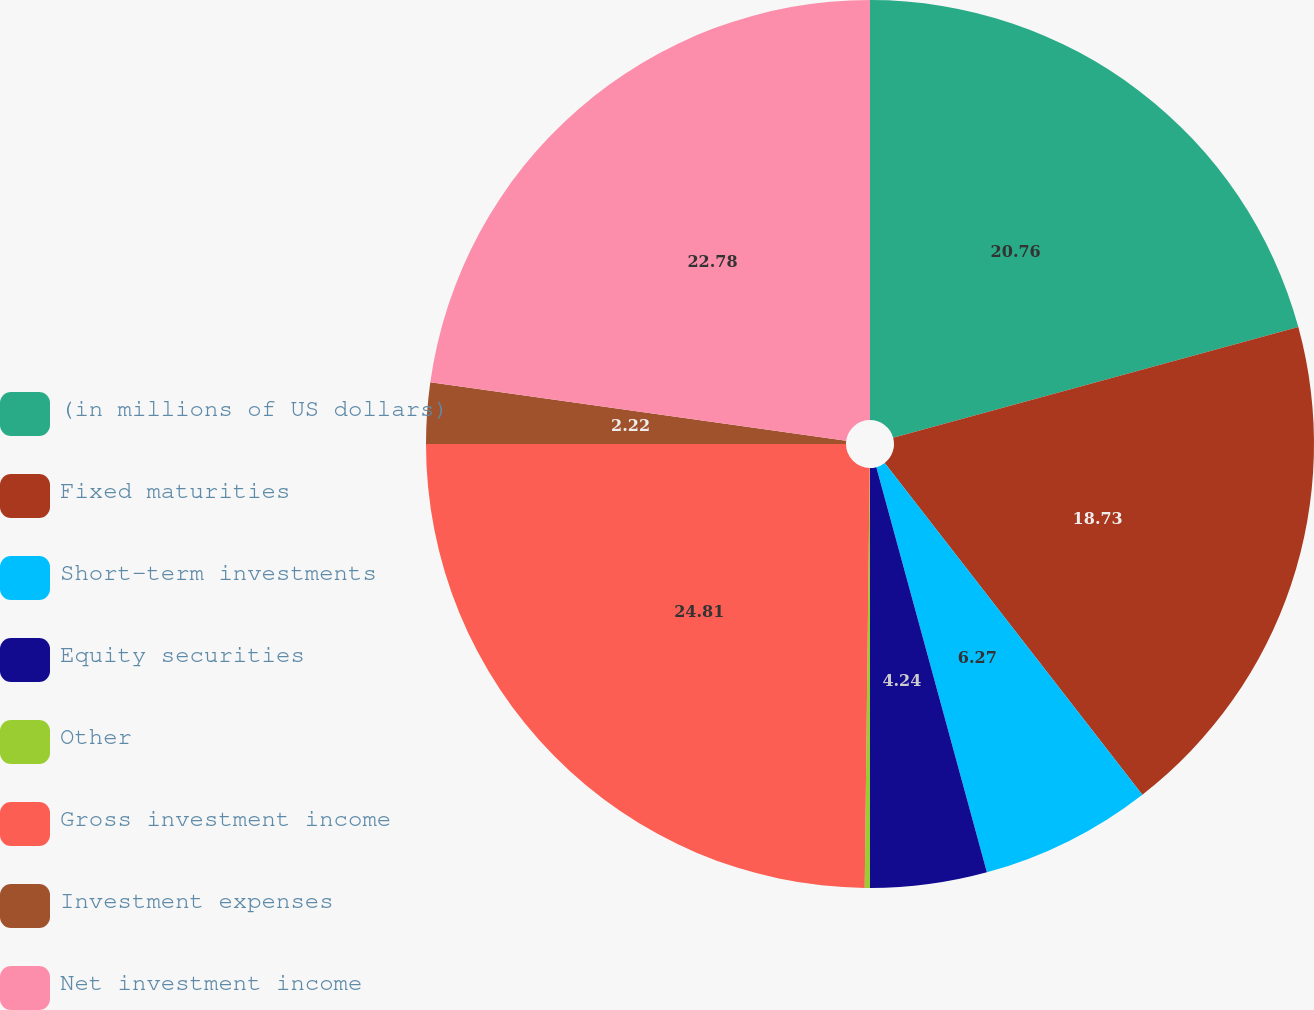<chart> <loc_0><loc_0><loc_500><loc_500><pie_chart><fcel>(in millions of US dollars)<fcel>Fixed maturities<fcel>Short-term investments<fcel>Equity securities<fcel>Other<fcel>Gross investment income<fcel>Investment expenses<fcel>Net investment income<nl><fcel>20.76%<fcel>18.73%<fcel>6.27%<fcel>4.24%<fcel>0.19%<fcel>24.81%<fcel>2.22%<fcel>22.78%<nl></chart> 